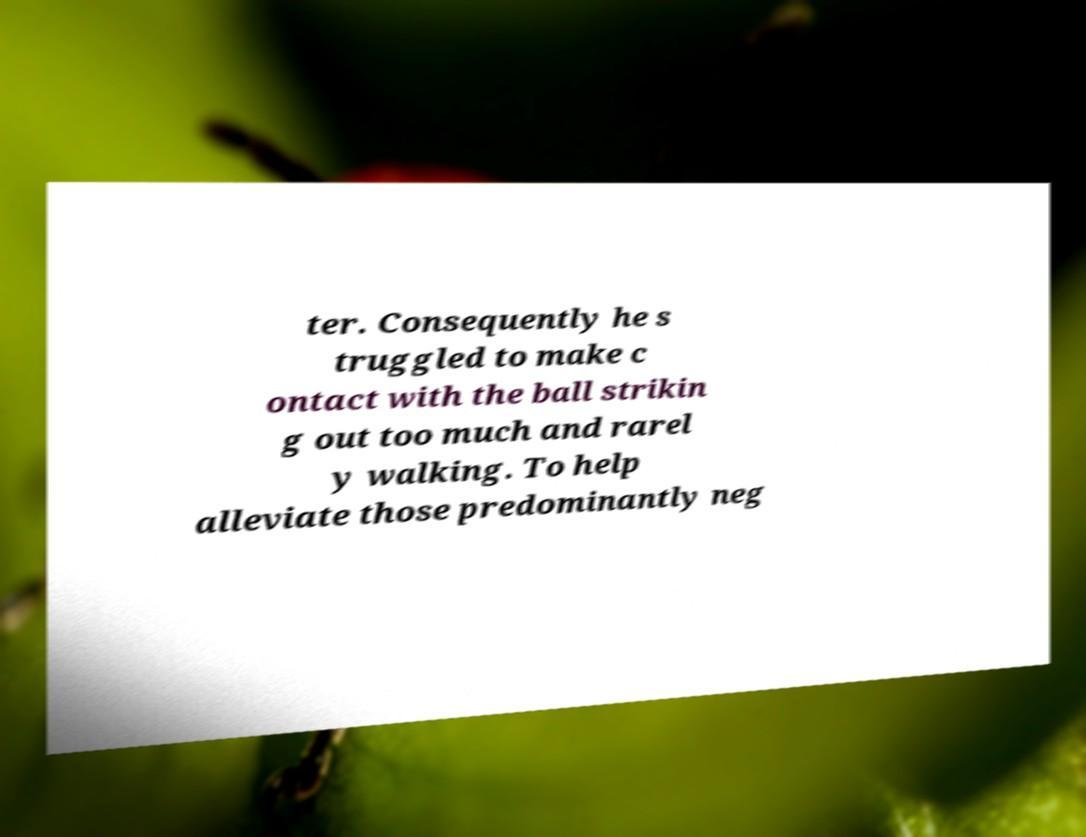Please read and relay the text visible in this image. What does it say? ter. Consequently he s truggled to make c ontact with the ball strikin g out too much and rarel y walking. To help alleviate those predominantly neg 